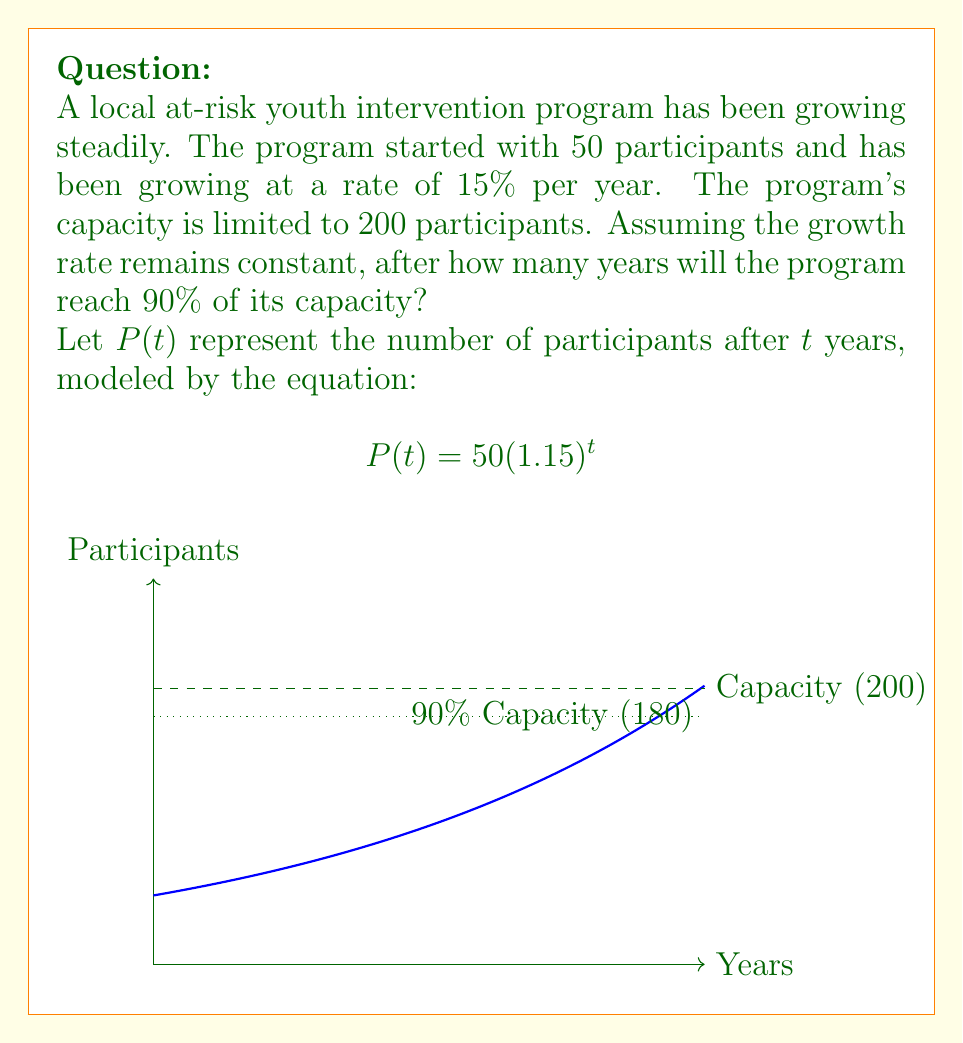Can you solve this math problem? Let's approach this step-by-step:

1) We need to find $t$ when $P(t)$ reaches 90% of 200, which is 180 participants.

2) Set up the equation:
   $$180 = 50(1.15)^t$$

3) Divide both sides by 50:
   $$3.6 = (1.15)^t$$

4) Take the natural logarithm of both sides:
   $$\ln(3.6) = t \ln(1.15)$$

5) Solve for $t$:
   $$t = \frac{\ln(3.6)}{\ln(1.15)}$$

6) Calculate:
   $$t = \frac{1.28093}{0.13976} \approx 9.1652$$

7) Since we can't have a fractional year, we round up to the next whole year.
Answer: 10 years 